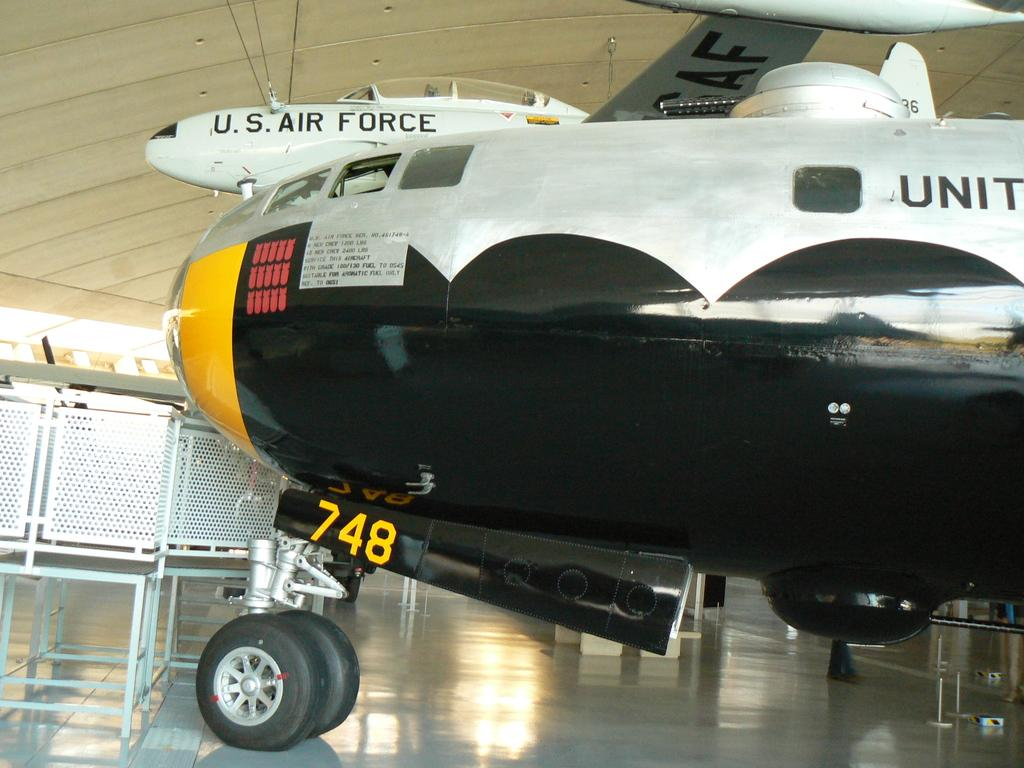What is the main subject of the image? The main subject of the image is an aircraft. Where is the aircraft located in the image? The aircraft is placed on a platform. What can be seen on the left side of the image? There are stands on the left side of the image. What is visible above the aircraft in the image? There is a roof visible in the image. What are the ropes used for in the image? The ropes are present in the image, but their specific purpose is not clear. Where is the lunchroom located in the image? There is no mention of a lunchroom in the image or the provided facts. What type of beast can be seen interacting with the aircraft in the image? There is no beast present in the image; it only features an aircraft, a platform, stands, a roof, and ropes. 